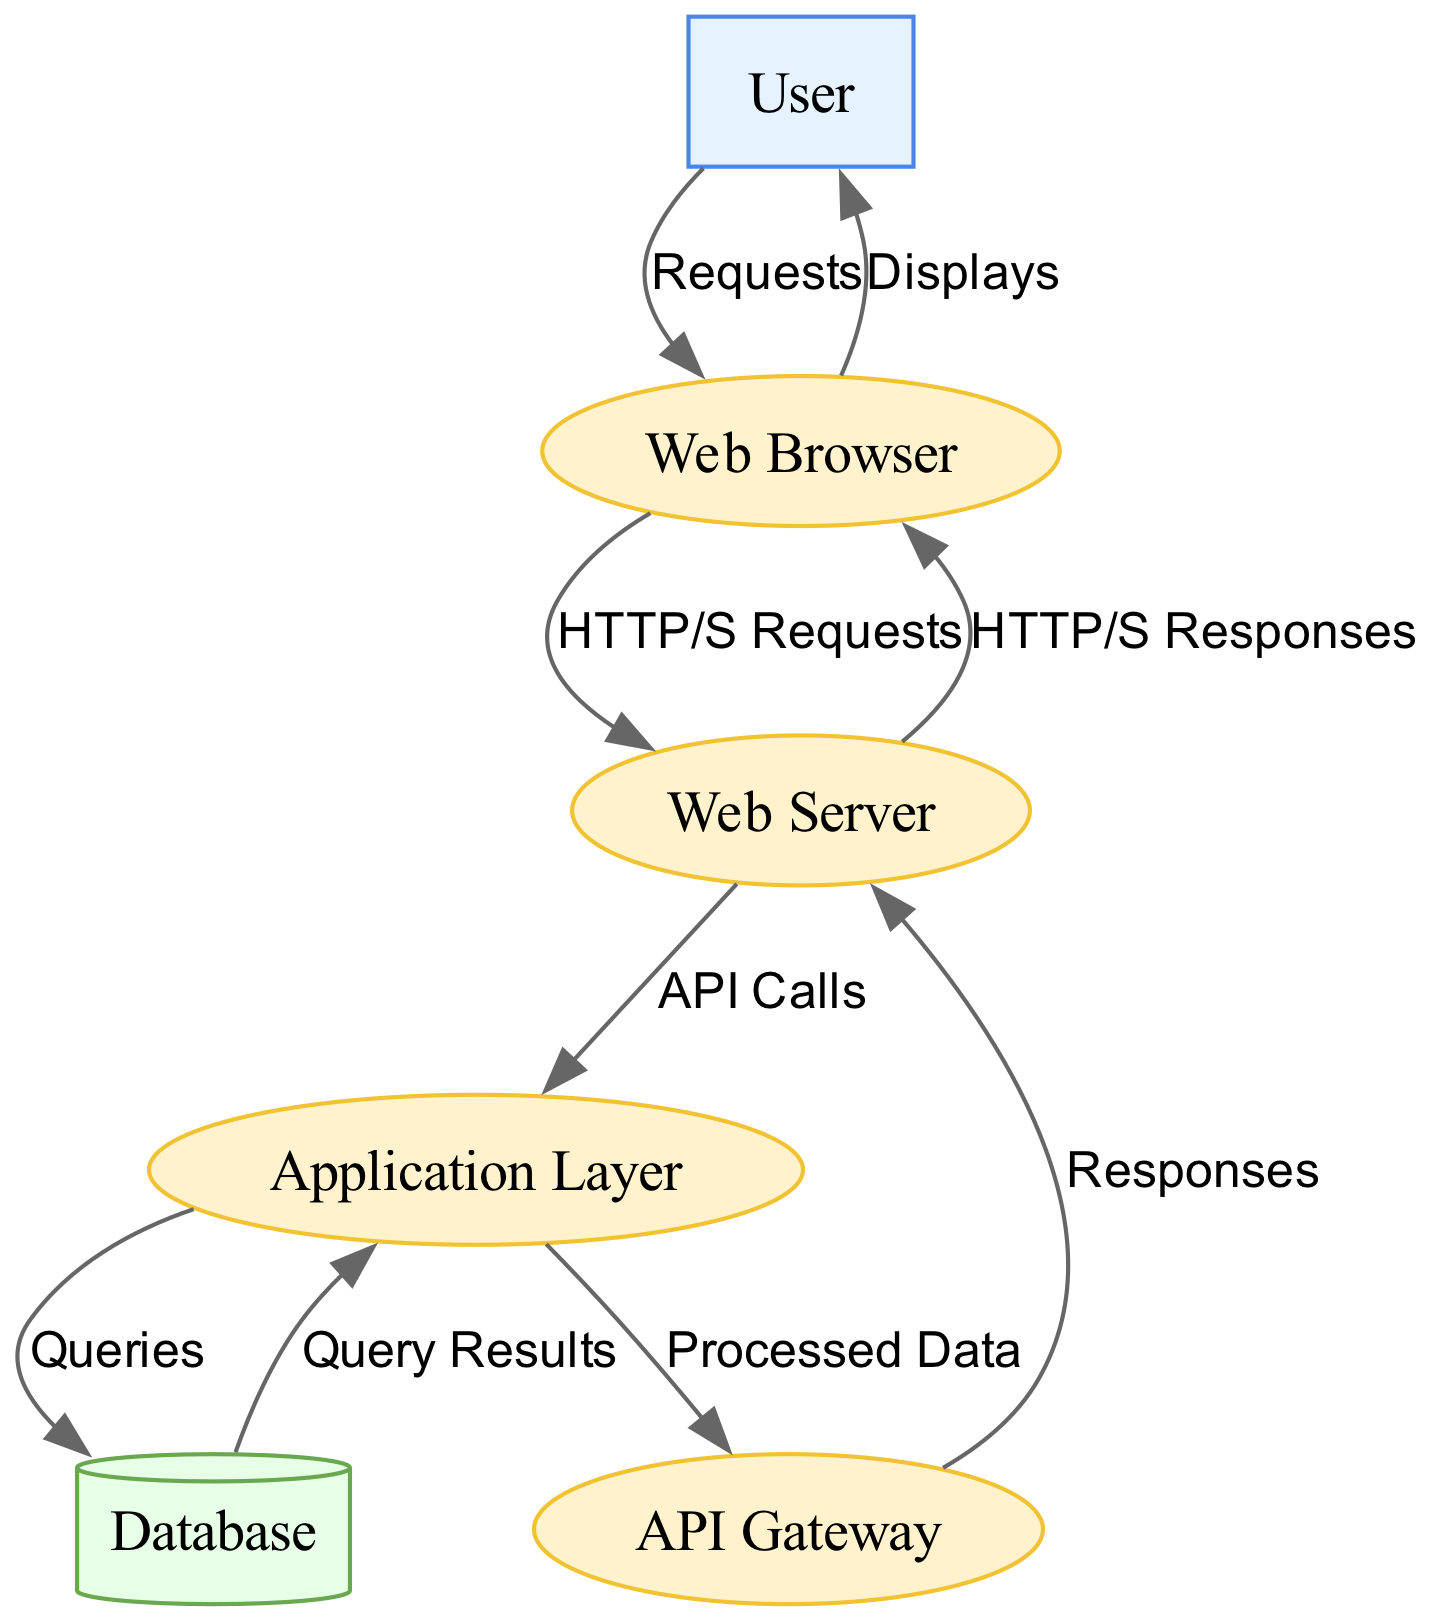What is the first external entity in the diagram? The first external entity listed in the diagram is "User." When analyzing the nodes, the "User" node is the first node defined with the type "external-entity."
Answer: User How many processes are there in total? The diagram contains four processes: "Web Browser," "Web Server," "Application Layer," and "API Gateway." By counting the nodes with the type "process," we find there are four.
Answer: 4 What type of data store is represented in the diagram? The diagram includes one data store labeled "Database." The node type for this entity is represented as "data-store," and the label matches "Database."
Answer: Database What is the label for the edge between the Web Server and the API Gateway? The label for the edge connecting "Web Server" to "API Gateway" is "Responses." By reading the edge definition in the diagram, this information can be directly extracted.
Answer: Responses Which process receives HTTP/S Requests from the Web Browser? The process that receives "HTTP/S Requests" from "Web Browser" is "Web Server." This can be observed in the edge connecting these two nodes.
Answer: Web Server What type of entity is the database in the diagram? The "Database" is classified as a "data-store." This classification comes from the type assigned to the "Database" node in the node definitions.
Answer: data-store How many edges are in the diagram? The diagram consists of eight edges connecting different nodes. By enumerating the relationships or connections presented between the nodes, we arrive at this total.
Answer: 8 What flows from the Application Layer to the Database? The flow from "Application Layer" to "Database" is labeled "Queries." Observing the edge connecting these nodes reveals this specific label.
Answer: Queries What entity does the User interact with first? The first entity the "User" interacts with is "Web Browser." The directional flow starts from "User" to "Web Browser" as shown in the diagram.
Answer: Web Browser 